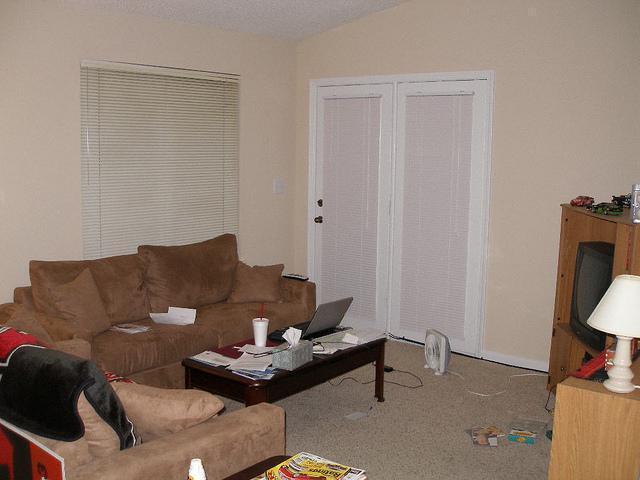What poses the biggest threat for a person to trip on?
Make your selection and explain in format: 'Answer: answer
Rationale: rationale.'
Options: Couch, cords, table, lamp. Answer: cords.
Rationale: The cords are dangerous. 